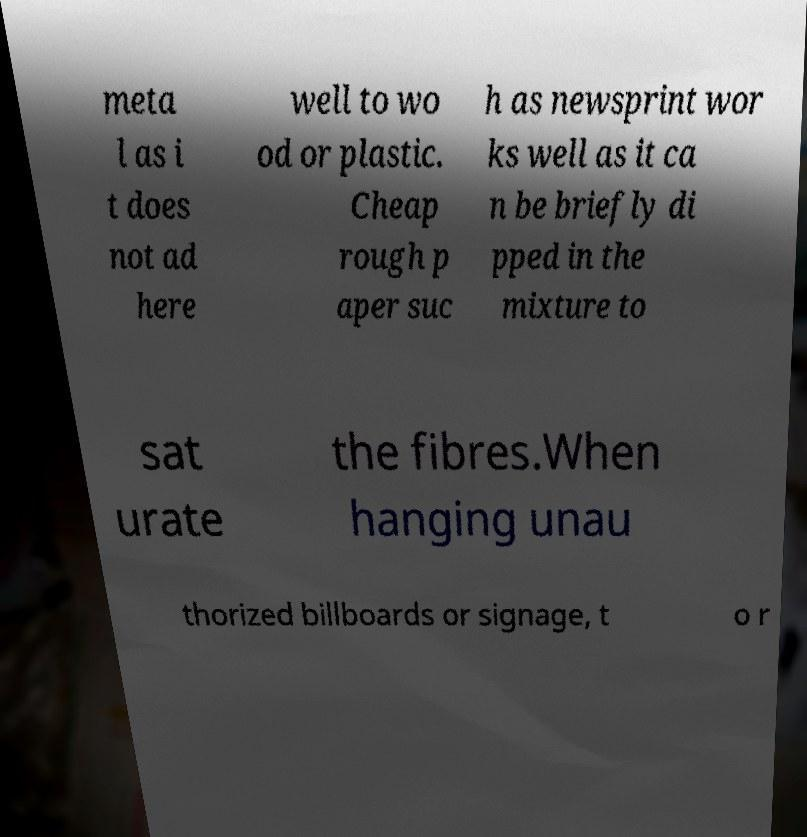What messages or text are displayed in this image? I need them in a readable, typed format. meta l as i t does not ad here well to wo od or plastic. Cheap rough p aper suc h as newsprint wor ks well as it ca n be briefly di pped in the mixture to sat urate the fibres.When hanging unau thorized billboards or signage, t o r 